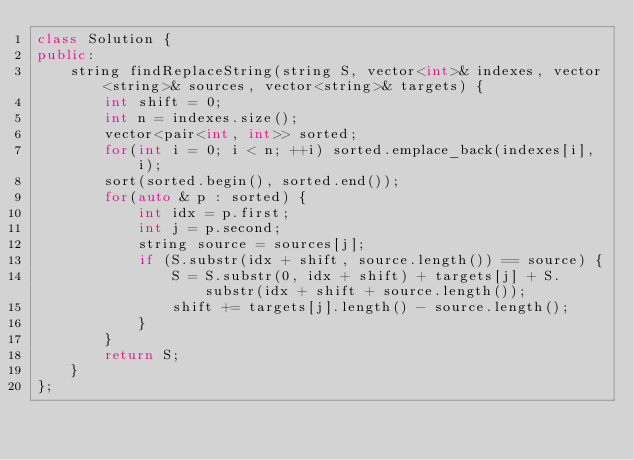Convert code to text. <code><loc_0><loc_0><loc_500><loc_500><_C++_>class Solution {
public:
    string findReplaceString(string S, vector<int>& indexes, vector<string>& sources, vector<string>& targets) {
        int shift = 0;
        int n = indexes.size();
        vector<pair<int, int>> sorted;
        for(int i = 0; i < n; ++i) sorted.emplace_back(indexes[i], i);
        sort(sorted.begin(), sorted.end());
        for(auto & p : sorted) {
            int idx = p.first;
            int j = p.second;
            string source = sources[j];
            if (S.substr(idx + shift, source.length()) == source) {
                S = S.substr(0, idx + shift) + targets[j] + S.substr(idx + shift + source.length());
                shift += targets[j].length() - source.length();
            }
        }
        return S;
    }
};
</code> 